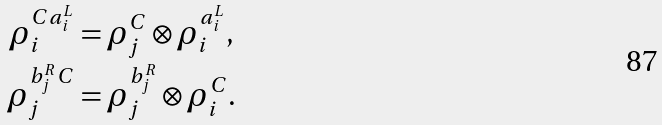<formula> <loc_0><loc_0><loc_500><loc_500>\rho _ { i } ^ { C a _ { i } ^ { L } } & = \rho _ { j } ^ { C } \otimes \rho _ { i } ^ { a _ { i } ^ { L } } , \\ \rho _ { j } ^ { b _ { j } ^ { R } C } & = \rho _ { j } ^ { b _ { j } ^ { R } } \otimes \rho _ { i } ^ { C } .</formula> 